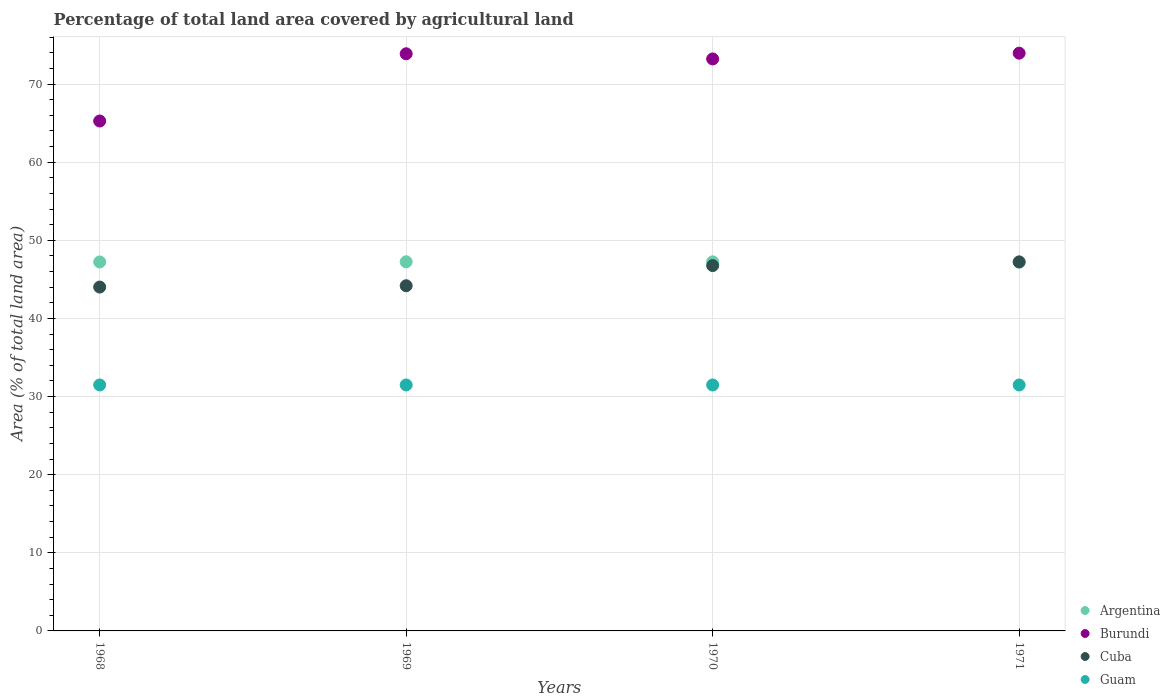How many different coloured dotlines are there?
Offer a very short reply. 4. Is the number of dotlines equal to the number of legend labels?
Make the answer very short. Yes. What is the percentage of agricultural land in Guam in 1971?
Give a very brief answer. 31.48. Across all years, what is the maximum percentage of agricultural land in Guam?
Provide a short and direct response. 31.48. Across all years, what is the minimum percentage of agricultural land in Cuba?
Provide a succinct answer. 44.01. In which year was the percentage of agricultural land in Argentina maximum?
Your response must be concise. 1969. In which year was the percentage of agricultural land in Cuba minimum?
Offer a very short reply. 1968. What is the total percentage of agricultural land in Guam in the graph?
Keep it short and to the point. 125.93. What is the difference between the percentage of agricultural land in Argentina in 1969 and that in 1971?
Offer a very short reply. 0.05. What is the difference between the percentage of agricultural land in Argentina in 1971 and the percentage of agricultural land in Guam in 1970?
Ensure brevity in your answer.  15.71. What is the average percentage of agricultural land in Guam per year?
Your response must be concise. 31.48. In the year 1969, what is the difference between the percentage of agricultural land in Argentina and percentage of agricultural land in Cuba?
Provide a short and direct response. 3.07. What is the ratio of the percentage of agricultural land in Cuba in 1968 to that in 1969?
Provide a short and direct response. 1. Is the difference between the percentage of agricultural land in Argentina in 1970 and 1971 greater than the difference between the percentage of agricultural land in Cuba in 1970 and 1971?
Ensure brevity in your answer.  Yes. What is the difference between the highest and the second highest percentage of agricultural land in Burundi?
Your answer should be very brief. 0.08. What is the difference between the highest and the lowest percentage of agricultural land in Burundi?
Make the answer very short. 8.68. In how many years, is the percentage of agricultural land in Burundi greater than the average percentage of agricultural land in Burundi taken over all years?
Your response must be concise. 3. Is the sum of the percentage of agricultural land in Cuba in 1968 and 1970 greater than the maximum percentage of agricultural land in Burundi across all years?
Give a very brief answer. Yes. Is it the case that in every year, the sum of the percentage of agricultural land in Cuba and percentage of agricultural land in Burundi  is greater than the sum of percentage of agricultural land in Guam and percentage of agricultural land in Argentina?
Your answer should be very brief. Yes. Does the percentage of agricultural land in Guam monotonically increase over the years?
Keep it short and to the point. No. Is the percentage of agricultural land in Argentina strictly greater than the percentage of agricultural land in Guam over the years?
Offer a very short reply. Yes. How many dotlines are there?
Ensure brevity in your answer.  4. What is the difference between two consecutive major ticks on the Y-axis?
Give a very brief answer. 10. Does the graph contain any zero values?
Your response must be concise. No. Does the graph contain grids?
Provide a short and direct response. Yes. How many legend labels are there?
Provide a short and direct response. 4. What is the title of the graph?
Keep it short and to the point. Percentage of total land area covered by agricultural land. Does "Tunisia" appear as one of the legend labels in the graph?
Your answer should be compact. No. What is the label or title of the X-axis?
Ensure brevity in your answer.  Years. What is the label or title of the Y-axis?
Ensure brevity in your answer.  Area (% of total land area). What is the Area (% of total land area) in Argentina in 1968?
Ensure brevity in your answer.  47.22. What is the Area (% of total land area) of Burundi in 1968?
Keep it short and to the point. 65.26. What is the Area (% of total land area) in Cuba in 1968?
Your answer should be very brief. 44.01. What is the Area (% of total land area) of Guam in 1968?
Your answer should be compact. 31.48. What is the Area (% of total land area) of Argentina in 1969?
Keep it short and to the point. 47.25. What is the Area (% of total land area) of Burundi in 1969?
Keep it short and to the point. 73.87. What is the Area (% of total land area) in Cuba in 1969?
Give a very brief answer. 44.18. What is the Area (% of total land area) of Guam in 1969?
Your answer should be compact. 31.48. What is the Area (% of total land area) of Argentina in 1970?
Keep it short and to the point. 47.24. What is the Area (% of total land area) in Burundi in 1970?
Your response must be concise. 73.21. What is the Area (% of total land area) in Cuba in 1970?
Your answer should be very brief. 46.76. What is the Area (% of total land area) of Guam in 1970?
Your answer should be very brief. 31.48. What is the Area (% of total land area) of Argentina in 1971?
Ensure brevity in your answer.  47.19. What is the Area (% of total land area) in Burundi in 1971?
Your answer should be compact. 73.95. What is the Area (% of total land area) of Cuba in 1971?
Your answer should be very brief. 47.23. What is the Area (% of total land area) of Guam in 1971?
Ensure brevity in your answer.  31.48. Across all years, what is the maximum Area (% of total land area) in Argentina?
Provide a succinct answer. 47.25. Across all years, what is the maximum Area (% of total land area) of Burundi?
Make the answer very short. 73.95. Across all years, what is the maximum Area (% of total land area) in Cuba?
Your answer should be very brief. 47.23. Across all years, what is the maximum Area (% of total land area) of Guam?
Give a very brief answer. 31.48. Across all years, what is the minimum Area (% of total land area) of Argentina?
Keep it short and to the point. 47.19. Across all years, what is the minimum Area (% of total land area) of Burundi?
Offer a terse response. 65.26. Across all years, what is the minimum Area (% of total land area) of Cuba?
Ensure brevity in your answer.  44.01. Across all years, what is the minimum Area (% of total land area) in Guam?
Offer a terse response. 31.48. What is the total Area (% of total land area) in Argentina in the graph?
Ensure brevity in your answer.  188.9. What is the total Area (% of total land area) of Burundi in the graph?
Offer a terse response. 286.29. What is the total Area (% of total land area) of Cuba in the graph?
Your response must be concise. 182.19. What is the total Area (% of total land area) in Guam in the graph?
Offer a very short reply. 125.93. What is the difference between the Area (% of total land area) of Argentina in 1968 and that in 1969?
Give a very brief answer. -0.02. What is the difference between the Area (% of total land area) of Burundi in 1968 and that in 1969?
Your answer should be compact. -8.61. What is the difference between the Area (% of total land area) of Cuba in 1968 and that in 1969?
Your answer should be compact. -0.17. What is the difference between the Area (% of total land area) in Argentina in 1968 and that in 1970?
Provide a short and direct response. -0.02. What is the difference between the Area (% of total land area) in Burundi in 1968 and that in 1970?
Give a very brief answer. -7.94. What is the difference between the Area (% of total land area) in Cuba in 1968 and that in 1970?
Your answer should be very brief. -2.75. What is the difference between the Area (% of total land area) of Guam in 1968 and that in 1970?
Provide a succinct answer. 0. What is the difference between the Area (% of total land area) in Argentina in 1968 and that in 1971?
Keep it short and to the point. 0.03. What is the difference between the Area (% of total land area) of Burundi in 1968 and that in 1971?
Your response must be concise. -8.68. What is the difference between the Area (% of total land area) of Cuba in 1968 and that in 1971?
Provide a succinct answer. -3.22. What is the difference between the Area (% of total land area) in Argentina in 1969 and that in 1970?
Keep it short and to the point. 0.01. What is the difference between the Area (% of total land area) of Burundi in 1969 and that in 1970?
Give a very brief answer. 0.66. What is the difference between the Area (% of total land area) of Cuba in 1969 and that in 1970?
Make the answer very short. -2.58. What is the difference between the Area (% of total land area) in Argentina in 1969 and that in 1971?
Your answer should be compact. 0.05. What is the difference between the Area (% of total land area) in Burundi in 1969 and that in 1971?
Give a very brief answer. -0.08. What is the difference between the Area (% of total land area) in Cuba in 1969 and that in 1971?
Your response must be concise. -3.05. What is the difference between the Area (% of total land area) of Guam in 1969 and that in 1971?
Offer a terse response. 0. What is the difference between the Area (% of total land area) of Argentina in 1970 and that in 1971?
Your answer should be very brief. 0.05. What is the difference between the Area (% of total land area) of Burundi in 1970 and that in 1971?
Offer a very short reply. -0.74. What is the difference between the Area (% of total land area) of Cuba in 1970 and that in 1971?
Provide a short and direct response. -0.47. What is the difference between the Area (% of total land area) in Guam in 1970 and that in 1971?
Your answer should be compact. 0. What is the difference between the Area (% of total land area) in Argentina in 1968 and the Area (% of total land area) in Burundi in 1969?
Make the answer very short. -26.65. What is the difference between the Area (% of total land area) in Argentina in 1968 and the Area (% of total land area) in Cuba in 1969?
Your answer should be very brief. 3.04. What is the difference between the Area (% of total land area) in Argentina in 1968 and the Area (% of total land area) in Guam in 1969?
Make the answer very short. 15.74. What is the difference between the Area (% of total land area) in Burundi in 1968 and the Area (% of total land area) in Cuba in 1969?
Provide a short and direct response. 21.08. What is the difference between the Area (% of total land area) in Burundi in 1968 and the Area (% of total land area) in Guam in 1969?
Give a very brief answer. 33.78. What is the difference between the Area (% of total land area) of Cuba in 1968 and the Area (% of total land area) of Guam in 1969?
Provide a short and direct response. 12.53. What is the difference between the Area (% of total land area) in Argentina in 1968 and the Area (% of total land area) in Burundi in 1970?
Your answer should be compact. -25.99. What is the difference between the Area (% of total land area) in Argentina in 1968 and the Area (% of total land area) in Cuba in 1970?
Keep it short and to the point. 0.46. What is the difference between the Area (% of total land area) in Argentina in 1968 and the Area (% of total land area) in Guam in 1970?
Your response must be concise. 15.74. What is the difference between the Area (% of total land area) in Burundi in 1968 and the Area (% of total land area) in Cuba in 1970?
Your response must be concise. 18.5. What is the difference between the Area (% of total land area) in Burundi in 1968 and the Area (% of total land area) in Guam in 1970?
Offer a terse response. 33.78. What is the difference between the Area (% of total land area) in Cuba in 1968 and the Area (% of total land area) in Guam in 1970?
Make the answer very short. 12.53. What is the difference between the Area (% of total land area) of Argentina in 1968 and the Area (% of total land area) of Burundi in 1971?
Your response must be concise. -26.73. What is the difference between the Area (% of total land area) of Argentina in 1968 and the Area (% of total land area) of Cuba in 1971?
Keep it short and to the point. -0.01. What is the difference between the Area (% of total land area) of Argentina in 1968 and the Area (% of total land area) of Guam in 1971?
Your answer should be compact. 15.74. What is the difference between the Area (% of total land area) in Burundi in 1968 and the Area (% of total land area) in Cuba in 1971?
Provide a short and direct response. 18.03. What is the difference between the Area (% of total land area) in Burundi in 1968 and the Area (% of total land area) in Guam in 1971?
Make the answer very short. 33.78. What is the difference between the Area (% of total land area) of Cuba in 1968 and the Area (% of total land area) of Guam in 1971?
Your answer should be very brief. 12.53. What is the difference between the Area (% of total land area) of Argentina in 1969 and the Area (% of total land area) of Burundi in 1970?
Provide a short and direct response. -25.96. What is the difference between the Area (% of total land area) of Argentina in 1969 and the Area (% of total land area) of Cuba in 1970?
Give a very brief answer. 0.49. What is the difference between the Area (% of total land area) in Argentina in 1969 and the Area (% of total land area) in Guam in 1970?
Offer a terse response. 15.77. What is the difference between the Area (% of total land area) of Burundi in 1969 and the Area (% of total land area) of Cuba in 1970?
Your answer should be compact. 27.11. What is the difference between the Area (% of total land area) in Burundi in 1969 and the Area (% of total land area) in Guam in 1970?
Offer a very short reply. 42.39. What is the difference between the Area (% of total land area) of Cuba in 1969 and the Area (% of total land area) of Guam in 1970?
Give a very brief answer. 12.7. What is the difference between the Area (% of total land area) of Argentina in 1969 and the Area (% of total land area) of Burundi in 1971?
Your response must be concise. -26.7. What is the difference between the Area (% of total land area) of Argentina in 1969 and the Area (% of total land area) of Cuba in 1971?
Keep it short and to the point. 0.01. What is the difference between the Area (% of total land area) in Argentina in 1969 and the Area (% of total land area) in Guam in 1971?
Your answer should be very brief. 15.77. What is the difference between the Area (% of total land area) in Burundi in 1969 and the Area (% of total land area) in Cuba in 1971?
Offer a very short reply. 26.64. What is the difference between the Area (% of total land area) in Burundi in 1969 and the Area (% of total land area) in Guam in 1971?
Offer a very short reply. 42.39. What is the difference between the Area (% of total land area) of Cuba in 1969 and the Area (% of total land area) of Guam in 1971?
Keep it short and to the point. 12.7. What is the difference between the Area (% of total land area) in Argentina in 1970 and the Area (% of total land area) in Burundi in 1971?
Provide a short and direct response. -26.71. What is the difference between the Area (% of total land area) of Argentina in 1970 and the Area (% of total land area) of Cuba in 1971?
Offer a terse response. 0. What is the difference between the Area (% of total land area) in Argentina in 1970 and the Area (% of total land area) in Guam in 1971?
Your answer should be compact. 15.76. What is the difference between the Area (% of total land area) of Burundi in 1970 and the Area (% of total land area) of Cuba in 1971?
Make the answer very short. 25.97. What is the difference between the Area (% of total land area) in Burundi in 1970 and the Area (% of total land area) in Guam in 1971?
Ensure brevity in your answer.  41.73. What is the difference between the Area (% of total land area) of Cuba in 1970 and the Area (% of total land area) of Guam in 1971?
Keep it short and to the point. 15.28. What is the average Area (% of total land area) in Argentina per year?
Your answer should be very brief. 47.23. What is the average Area (% of total land area) in Burundi per year?
Provide a succinct answer. 71.57. What is the average Area (% of total land area) of Cuba per year?
Your answer should be compact. 45.55. What is the average Area (% of total land area) of Guam per year?
Offer a very short reply. 31.48. In the year 1968, what is the difference between the Area (% of total land area) of Argentina and Area (% of total land area) of Burundi?
Your response must be concise. -18.04. In the year 1968, what is the difference between the Area (% of total land area) of Argentina and Area (% of total land area) of Cuba?
Your answer should be very brief. 3.21. In the year 1968, what is the difference between the Area (% of total land area) in Argentina and Area (% of total land area) in Guam?
Your answer should be compact. 15.74. In the year 1968, what is the difference between the Area (% of total land area) of Burundi and Area (% of total land area) of Cuba?
Your answer should be very brief. 21.25. In the year 1968, what is the difference between the Area (% of total land area) of Burundi and Area (% of total land area) of Guam?
Offer a terse response. 33.78. In the year 1968, what is the difference between the Area (% of total land area) in Cuba and Area (% of total land area) in Guam?
Your response must be concise. 12.53. In the year 1969, what is the difference between the Area (% of total land area) of Argentina and Area (% of total land area) of Burundi?
Your answer should be very brief. -26.62. In the year 1969, what is the difference between the Area (% of total land area) in Argentina and Area (% of total land area) in Cuba?
Your answer should be very brief. 3.07. In the year 1969, what is the difference between the Area (% of total land area) in Argentina and Area (% of total land area) in Guam?
Provide a succinct answer. 15.77. In the year 1969, what is the difference between the Area (% of total land area) of Burundi and Area (% of total land area) of Cuba?
Your answer should be very brief. 29.69. In the year 1969, what is the difference between the Area (% of total land area) in Burundi and Area (% of total land area) in Guam?
Offer a terse response. 42.39. In the year 1969, what is the difference between the Area (% of total land area) in Cuba and Area (% of total land area) in Guam?
Ensure brevity in your answer.  12.7. In the year 1970, what is the difference between the Area (% of total land area) in Argentina and Area (% of total land area) in Burundi?
Your answer should be very brief. -25.97. In the year 1970, what is the difference between the Area (% of total land area) in Argentina and Area (% of total land area) in Cuba?
Offer a very short reply. 0.48. In the year 1970, what is the difference between the Area (% of total land area) in Argentina and Area (% of total land area) in Guam?
Provide a succinct answer. 15.76. In the year 1970, what is the difference between the Area (% of total land area) in Burundi and Area (% of total land area) in Cuba?
Your response must be concise. 26.45. In the year 1970, what is the difference between the Area (% of total land area) of Burundi and Area (% of total land area) of Guam?
Make the answer very short. 41.73. In the year 1970, what is the difference between the Area (% of total land area) in Cuba and Area (% of total land area) in Guam?
Make the answer very short. 15.28. In the year 1971, what is the difference between the Area (% of total land area) in Argentina and Area (% of total land area) in Burundi?
Your answer should be compact. -26.76. In the year 1971, what is the difference between the Area (% of total land area) of Argentina and Area (% of total land area) of Cuba?
Keep it short and to the point. -0.04. In the year 1971, what is the difference between the Area (% of total land area) in Argentina and Area (% of total land area) in Guam?
Make the answer very short. 15.71. In the year 1971, what is the difference between the Area (% of total land area) of Burundi and Area (% of total land area) of Cuba?
Provide a short and direct response. 26.71. In the year 1971, what is the difference between the Area (% of total land area) in Burundi and Area (% of total land area) in Guam?
Provide a short and direct response. 42.47. In the year 1971, what is the difference between the Area (% of total land area) of Cuba and Area (% of total land area) of Guam?
Your answer should be compact. 15.75. What is the ratio of the Area (% of total land area) of Burundi in 1968 to that in 1969?
Make the answer very short. 0.88. What is the ratio of the Area (% of total land area) in Cuba in 1968 to that in 1969?
Provide a succinct answer. 1. What is the ratio of the Area (% of total land area) of Argentina in 1968 to that in 1970?
Your answer should be very brief. 1. What is the ratio of the Area (% of total land area) of Burundi in 1968 to that in 1970?
Offer a very short reply. 0.89. What is the ratio of the Area (% of total land area) in Cuba in 1968 to that in 1970?
Your response must be concise. 0.94. What is the ratio of the Area (% of total land area) of Argentina in 1968 to that in 1971?
Give a very brief answer. 1. What is the ratio of the Area (% of total land area) in Burundi in 1968 to that in 1971?
Your answer should be compact. 0.88. What is the ratio of the Area (% of total land area) of Cuba in 1968 to that in 1971?
Your response must be concise. 0.93. What is the ratio of the Area (% of total land area) in Guam in 1968 to that in 1971?
Your answer should be compact. 1. What is the ratio of the Area (% of total land area) in Argentina in 1969 to that in 1970?
Your answer should be compact. 1. What is the ratio of the Area (% of total land area) in Cuba in 1969 to that in 1970?
Give a very brief answer. 0.94. What is the ratio of the Area (% of total land area) of Argentina in 1969 to that in 1971?
Provide a succinct answer. 1. What is the ratio of the Area (% of total land area) of Cuba in 1969 to that in 1971?
Give a very brief answer. 0.94. What is the ratio of the Area (% of total land area) of Guam in 1969 to that in 1971?
Offer a terse response. 1. What is the ratio of the Area (% of total land area) in Burundi in 1970 to that in 1971?
Make the answer very short. 0.99. What is the difference between the highest and the second highest Area (% of total land area) of Argentina?
Make the answer very short. 0.01. What is the difference between the highest and the second highest Area (% of total land area) in Burundi?
Keep it short and to the point. 0.08. What is the difference between the highest and the second highest Area (% of total land area) in Cuba?
Offer a terse response. 0.47. What is the difference between the highest and the second highest Area (% of total land area) of Guam?
Give a very brief answer. 0. What is the difference between the highest and the lowest Area (% of total land area) of Argentina?
Provide a succinct answer. 0.05. What is the difference between the highest and the lowest Area (% of total land area) in Burundi?
Offer a very short reply. 8.68. What is the difference between the highest and the lowest Area (% of total land area) of Cuba?
Provide a short and direct response. 3.22. 